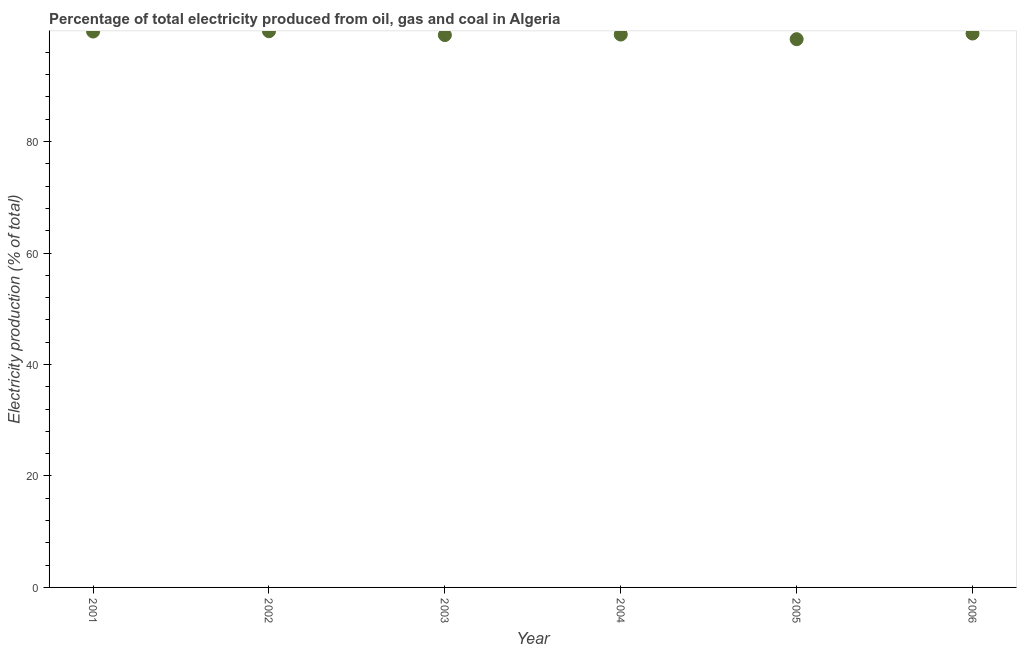What is the electricity production in 2004?
Provide a short and direct response. 99.2. Across all years, what is the maximum electricity production?
Offer a very short reply. 99.79. Across all years, what is the minimum electricity production?
Ensure brevity in your answer.  98.36. In which year was the electricity production maximum?
Make the answer very short. 2002. What is the sum of the electricity production?
Give a very brief answer. 595.58. What is the difference between the electricity production in 2004 and 2006?
Make the answer very short. -0.18. What is the average electricity production per year?
Offer a very short reply. 99.26. What is the median electricity production?
Offer a terse response. 99.29. In how many years, is the electricity production greater than 8 %?
Your response must be concise. 6. What is the ratio of the electricity production in 2001 to that in 2002?
Your answer should be very brief. 1. What is the difference between the highest and the second highest electricity production?
Give a very brief answer. 0.05. What is the difference between the highest and the lowest electricity production?
Make the answer very short. 1.43. How many dotlines are there?
Your response must be concise. 1. What is the difference between two consecutive major ticks on the Y-axis?
Your response must be concise. 20. Are the values on the major ticks of Y-axis written in scientific E-notation?
Ensure brevity in your answer.  No. What is the title of the graph?
Provide a short and direct response. Percentage of total electricity produced from oil, gas and coal in Algeria. What is the label or title of the X-axis?
Offer a very short reply. Year. What is the label or title of the Y-axis?
Ensure brevity in your answer.  Electricity production (% of total). What is the Electricity production (% of total) in 2001?
Offer a terse response. 99.74. What is the Electricity production (% of total) in 2002?
Your answer should be compact. 99.79. What is the Electricity production (% of total) in 2003?
Keep it short and to the point. 99.1. What is the Electricity production (% of total) in 2004?
Your answer should be very brief. 99.2. What is the Electricity production (% of total) in 2005?
Provide a short and direct response. 98.36. What is the Electricity production (% of total) in 2006?
Offer a terse response. 99.38. What is the difference between the Electricity production (% of total) in 2001 and 2002?
Your answer should be very brief. -0.05. What is the difference between the Electricity production (% of total) in 2001 and 2003?
Offer a terse response. 0.64. What is the difference between the Electricity production (% of total) in 2001 and 2004?
Your answer should be compact. 0.54. What is the difference between the Electricity production (% of total) in 2001 and 2005?
Provide a succinct answer. 1.38. What is the difference between the Electricity production (% of total) in 2001 and 2006?
Your answer should be very brief. 0.36. What is the difference between the Electricity production (% of total) in 2002 and 2003?
Give a very brief answer. 0.69. What is the difference between the Electricity production (% of total) in 2002 and 2004?
Make the answer very short. 0.6. What is the difference between the Electricity production (% of total) in 2002 and 2005?
Offer a very short reply. 1.43. What is the difference between the Electricity production (% of total) in 2002 and 2006?
Your response must be concise. 0.41. What is the difference between the Electricity production (% of total) in 2003 and 2004?
Give a very brief answer. -0.09. What is the difference between the Electricity production (% of total) in 2003 and 2005?
Your answer should be compact. 0.74. What is the difference between the Electricity production (% of total) in 2003 and 2006?
Your answer should be compact. -0.28. What is the difference between the Electricity production (% of total) in 2004 and 2005?
Your response must be concise. 0.83. What is the difference between the Electricity production (% of total) in 2004 and 2006?
Give a very brief answer. -0.18. What is the difference between the Electricity production (% of total) in 2005 and 2006?
Give a very brief answer. -1.02. What is the ratio of the Electricity production (% of total) in 2001 to that in 2002?
Offer a terse response. 1. What is the ratio of the Electricity production (% of total) in 2001 to that in 2005?
Provide a succinct answer. 1.01. What is the ratio of the Electricity production (% of total) in 2001 to that in 2006?
Ensure brevity in your answer.  1. What is the ratio of the Electricity production (% of total) in 2002 to that in 2004?
Offer a terse response. 1.01. What is the ratio of the Electricity production (% of total) in 2002 to that in 2005?
Provide a succinct answer. 1.01. What is the ratio of the Electricity production (% of total) in 2002 to that in 2006?
Offer a very short reply. 1. What is the ratio of the Electricity production (% of total) in 2004 to that in 2005?
Your answer should be compact. 1.01. 